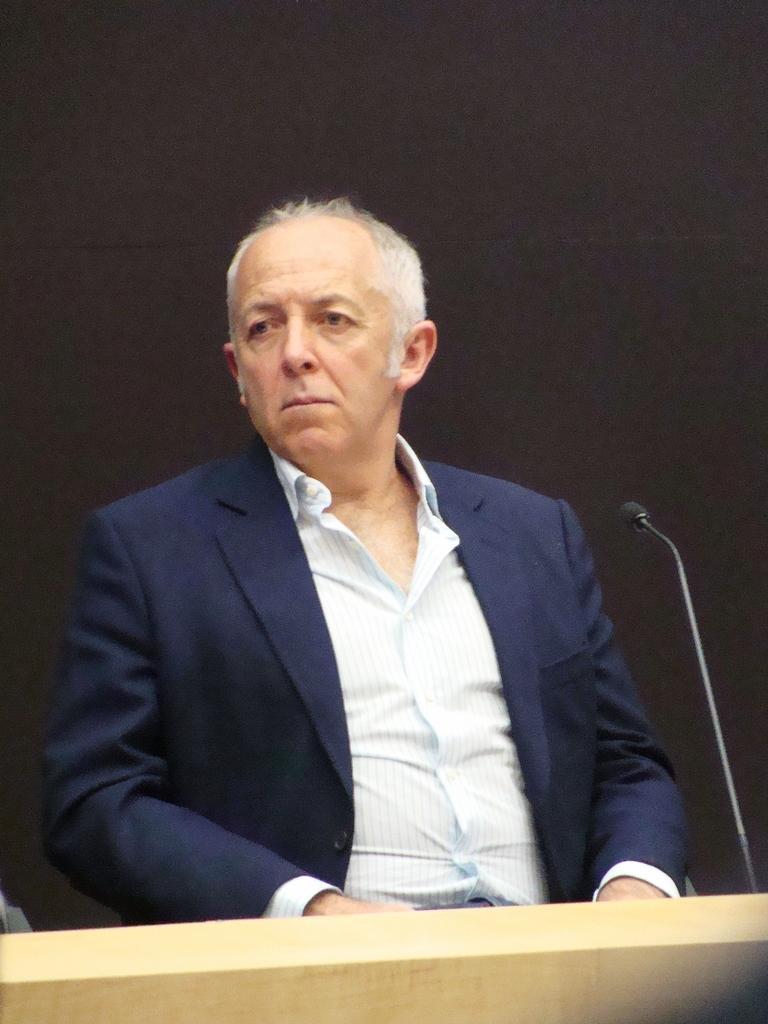Describe this image in one or two sentences. This picture seems to be clicked inside. In the center there is a person wearing suit and seems to be sitting. In the foreground we can see the wooden object and we can see a microphone. In the background there is an object seems to be the wall. 